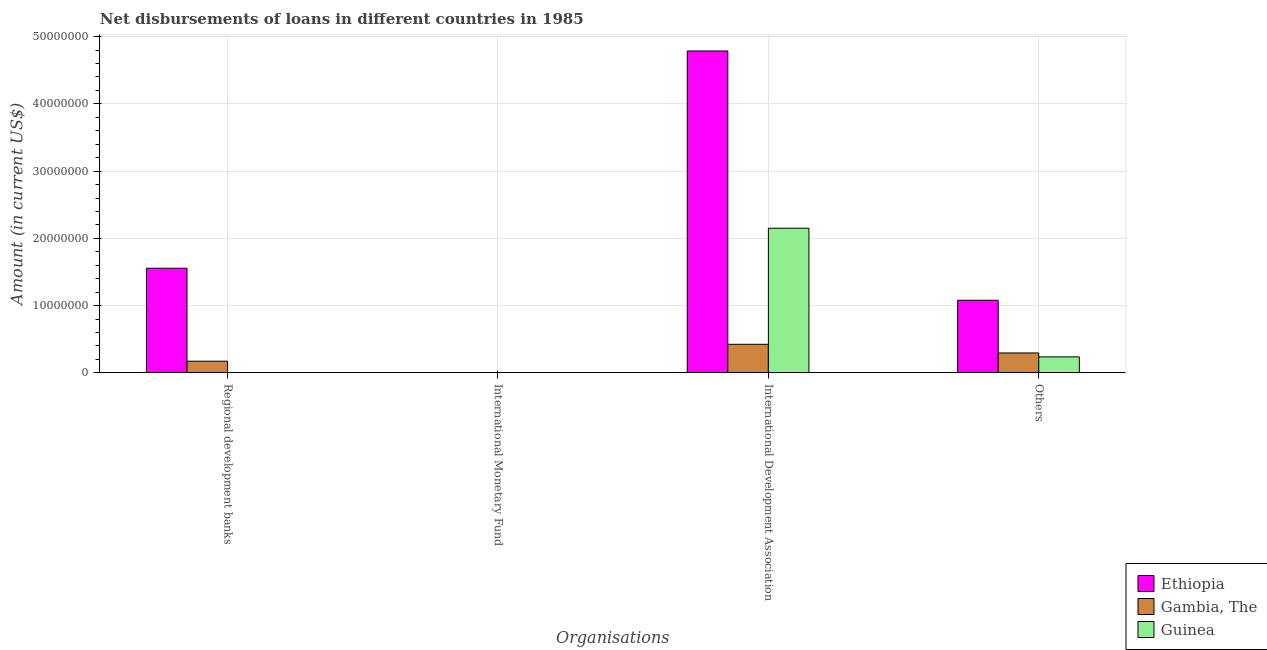How many different coloured bars are there?
Offer a terse response. 3. How many bars are there on the 2nd tick from the left?
Offer a very short reply. 0. What is the label of the 3rd group of bars from the left?
Make the answer very short. International Development Association. What is the amount of loan disimbursed by other organisations in Ethiopia?
Offer a terse response. 1.08e+07. Across all countries, what is the maximum amount of loan disimbursed by regional development banks?
Offer a very short reply. 1.56e+07. Across all countries, what is the minimum amount of loan disimbursed by international development association?
Your answer should be compact. 4.25e+06. In which country was the amount of loan disimbursed by international development association maximum?
Give a very brief answer. Ethiopia. What is the total amount of loan disimbursed by international monetary fund in the graph?
Your answer should be very brief. 0. What is the difference between the amount of loan disimbursed by international development association in Guinea and that in Gambia, The?
Offer a terse response. 1.73e+07. What is the difference between the amount of loan disimbursed by international development association in Guinea and the amount of loan disimbursed by other organisations in Gambia, The?
Ensure brevity in your answer.  1.85e+07. What is the difference between the amount of loan disimbursed by other organisations and amount of loan disimbursed by regional development banks in Gambia, The?
Your answer should be compact. 1.23e+06. What is the ratio of the amount of loan disimbursed by international development association in Guinea to that in Ethiopia?
Provide a succinct answer. 0.45. Is the amount of loan disimbursed by international development association in Gambia, The less than that in Guinea?
Your answer should be very brief. Yes. Is the difference between the amount of loan disimbursed by other organisations in Guinea and Ethiopia greater than the difference between the amount of loan disimbursed by international development association in Guinea and Ethiopia?
Your answer should be compact. Yes. What is the difference between the highest and the second highest amount of loan disimbursed by international development association?
Give a very brief answer. 2.64e+07. What is the difference between the highest and the lowest amount of loan disimbursed by other organisations?
Your answer should be compact. 8.42e+06. In how many countries, is the amount of loan disimbursed by international monetary fund greater than the average amount of loan disimbursed by international monetary fund taken over all countries?
Your answer should be very brief. 0. Is the sum of the amount of loan disimbursed by other organisations in Guinea and Gambia, The greater than the maximum amount of loan disimbursed by international development association across all countries?
Give a very brief answer. No. Is it the case that in every country, the sum of the amount of loan disimbursed by regional development banks and amount of loan disimbursed by international development association is greater than the sum of amount of loan disimbursed by international monetary fund and amount of loan disimbursed by other organisations?
Offer a terse response. No. How many bars are there?
Your answer should be very brief. 8. Are all the bars in the graph horizontal?
Provide a succinct answer. No. How many countries are there in the graph?
Your response must be concise. 3. What is the difference between two consecutive major ticks on the Y-axis?
Ensure brevity in your answer.  1.00e+07. Are the values on the major ticks of Y-axis written in scientific E-notation?
Make the answer very short. No. Does the graph contain grids?
Your answer should be very brief. Yes. How many legend labels are there?
Offer a terse response. 3. How are the legend labels stacked?
Give a very brief answer. Vertical. What is the title of the graph?
Ensure brevity in your answer.  Net disbursements of loans in different countries in 1985. What is the label or title of the X-axis?
Offer a terse response. Organisations. What is the Amount (in current US$) of Ethiopia in Regional development banks?
Keep it short and to the point. 1.56e+07. What is the Amount (in current US$) in Gambia, The in Regional development banks?
Provide a succinct answer. 1.74e+06. What is the Amount (in current US$) of Guinea in Regional development banks?
Your response must be concise. 0. What is the Amount (in current US$) in Ethiopia in International Monetary Fund?
Your answer should be very brief. 0. What is the Amount (in current US$) in Guinea in International Monetary Fund?
Your response must be concise. 0. What is the Amount (in current US$) in Ethiopia in International Development Association?
Make the answer very short. 4.79e+07. What is the Amount (in current US$) in Gambia, The in International Development Association?
Ensure brevity in your answer.  4.25e+06. What is the Amount (in current US$) of Guinea in International Development Association?
Ensure brevity in your answer.  2.15e+07. What is the Amount (in current US$) of Ethiopia in Others?
Provide a succinct answer. 1.08e+07. What is the Amount (in current US$) of Gambia, The in Others?
Provide a succinct answer. 2.96e+06. What is the Amount (in current US$) of Guinea in Others?
Offer a very short reply. 2.38e+06. Across all Organisations, what is the maximum Amount (in current US$) in Ethiopia?
Ensure brevity in your answer.  4.79e+07. Across all Organisations, what is the maximum Amount (in current US$) in Gambia, The?
Provide a short and direct response. 4.25e+06. Across all Organisations, what is the maximum Amount (in current US$) of Guinea?
Make the answer very short. 2.15e+07. Across all Organisations, what is the minimum Amount (in current US$) of Gambia, The?
Give a very brief answer. 0. What is the total Amount (in current US$) of Ethiopia in the graph?
Keep it short and to the point. 7.42e+07. What is the total Amount (in current US$) of Gambia, The in the graph?
Offer a very short reply. 8.94e+06. What is the total Amount (in current US$) of Guinea in the graph?
Give a very brief answer. 2.39e+07. What is the difference between the Amount (in current US$) in Ethiopia in Regional development banks and that in International Development Association?
Provide a short and direct response. -3.23e+07. What is the difference between the Amount (in current US$) of Gambia, The in Regional development banks and that in International Development Association?
Give a very brief answer. -2.51e+06. What is the difference between the Amount (in current US$) in Ethiopia in Regional development banks and that in Others?
Your answer should be very brief. 4.76e+06. What is the difference between the Amount (in current US$) of Gambia, The in Regional development banks and that in Others?
Provide a succinct answer. -1.23e+06. What is the difference between the Amount (in current US$) in Ethiopia in International Development Association and that in Others?
Offer a very short reply. 3.71e+07. What is the difference between the Amount (in current US$) in Gambia, The in International Development Association and that in Others?
Your response must be concise. 1.28e+06. What is the difference between the Amount (in current US$) of Guinea in International Development Association and that in Others?
Make the answer very short. 1.91e+07. What is the difference between the Amount (in current US$) in Ethiopia in Regional development banks and the Amount (in current US$) in Gambia, The in International Development Association?
Give a very brief answer. 1.13e+07. What is the difference between the Amount (in current US$) in Ethiopia in Regional development banks and the Amount (in current US$) in Guinea in International Development Association?
Your response must be concise. -5.95e+06. What is the difference between the Amount (in current US$) of Gambia, The in Regional development banks and the Amount (in current US$) of Guinea in International Development Association?
Keep it short and to the point. -1.98e+07. What is the difference between the Amount (in current US$) in Ethiopia in Regional development banks and the Amount (in current US$) in Gambia, The in Others?
Provide a succinct answer. 1.26e+07. What is the difference between the Amount (in current US$) of Ethiopia in Regional development banks and the Amount (in current US$) of Guinea in Others?
Your answer should be compact. 1.32e+07. What is the difference between the Amount (in current US$) of Gambia, The in Regional development banks and the Amount (in current US$) of Guinea in Others?
Provide a succinct answer. -6.42e+05. What is the difference between the Amount (in current US$) of Ethiopia in International Development Association and the Amount (in current US$) of Gambia, The in Others?
Keep it short and to the point. 4.49e+07. What is the difference between the Amount (in current US$) in Ethiopia in International Development Association and the Amount (in current US$) in Guinea in Others?
Give a very brief answer. 4.55e+07. What is the difference between the Amount (in current US$) in Gambia, The in International Development Association and the Amount (in current US$) in Guinea in Others?
Make the answer very short. 1.87e+06. What is the average Amount (in current US$) in Ethiopia per Organisations?
Offer a terse response. 1.86e+07. What is the average Amount (in current US$) in Gambia, The per Organisations?
Your answer should be compact. 2.24e+06. What is the average Amount (in current US$) of Guinea per Organisations?
Your response must be concise. 5.97e+06. What is the difference between the Amount (in current US$) in Ethiopia and Amount (in current US$) in Gambia, The in Regional development banks?
Keep it short and to the point. 1.38e+07. What is the difference between the Amount (in current US$) in Ethiopia and Amount (in current US$) in Gambia, The in International Development Association?
Your response must be concise. 4.36e+07. What is the difference between the Amount (in current US$) in Ethiopia and Amount (in current US$) in Guinea in International Development Association?
Give a very brief answer. 2.64e+07. What is the difference between the Amount (in current US$) in Gambia, The and Amount (in current US$) in Guinea in International Development Association?
Your answer should be compact. -1.73e+07. What is the difference between the Amount (in current US$) in Ethiopia and Amount (in current US$) in Gambia, The in Others?
Offer a very short reply. 7.83e+06. What is the difference between the Amount (in current US$) of Ethiopia and Amount (in current US$) of Guinea in Others?
Ensure brevity in your answer.  8.42e+06. What is the difference between the Amount (in current US$) of Gambia, The and Amount (in current US$) of Guinea in Others?
Give a very brief answer. 5.86e+05. What is the ratio of the Amount (in current US$) of Ethiopia in Regional development banks to that in International Development Association?
Offer a terse response. 0.33. What is the ratio of the Amount (in current US$) of Gambia, The in Regional development banks to that in International Development Association?
Provide a short and direct response. 0.41. What is the ratio of the Amount (in current US$) in Ethiopia in Regional development banks to that in Others?
Give a very brief answer. 1.44. What is the ratio of the Amount (in current US$) in Gambia, The in Regional development banks to that in Others?
Your answer should be compact. 0.59. What is the ratio of the Amount (in current US$) of Ethiopia in International Development Association to that in Others?
Make the answer very short. 4.43. What is the ratio of the Amount (in current US$) of Gambia, The in International Development Association to that in Others?
Ensure brevity in your answer.  1.43. What is the ratio of the Amount (in current US$) of Guinea in International Development Association to that in Others?
Provide a succinct answer. 9.05. What is the difference between the highest and the second highest Amount (in current US$) of Ethiopia?
Give a very brief answer. 3.23e+07. What is the difference between the highest and the second highest Amount (in current US$) in Gambia, The?
Provide a short and direct response. 1.28e+06. What is the difference between the highest and the lowest Amount (in current US$) in Ethiopia?
Provide a short and direct response. 4.79e+07. What is the difference between the highest and the lowest Amount (in current US$) in Gambia, The?
Keep it short and to the point. 4.25e+06. What is the difference between the highest and the lowest Amount (in current US$) of Guinea?
Provide a succinct answer. 2.15e+07. 